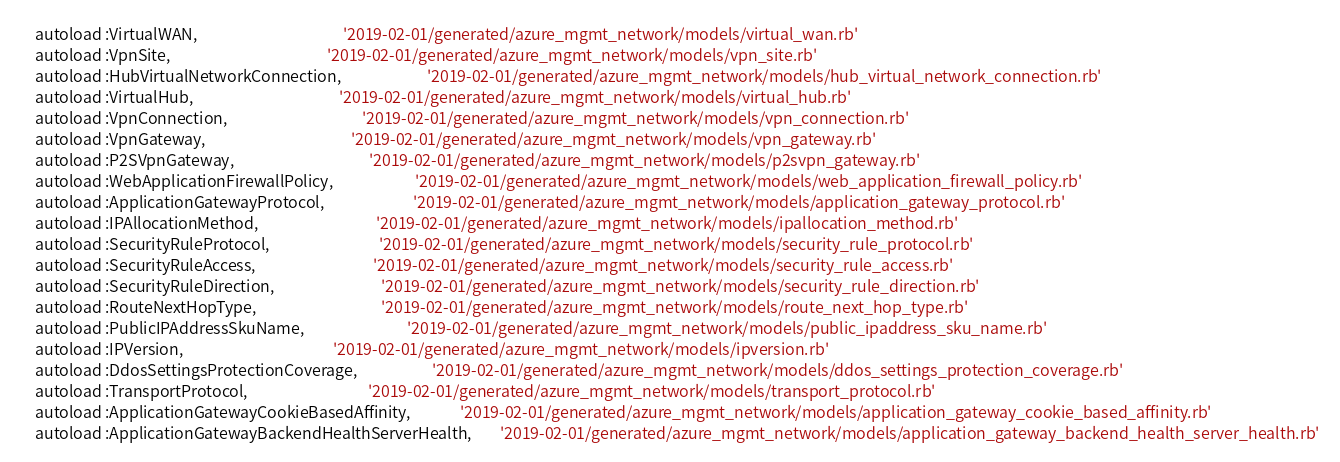Convert code to text. <code><loc_0><loc_0><loc_500><loc_500><_Ruby_>    autoload :VirtualWAN,                                         '2019-02-01/generated/azure_mgmt_network/models/virtual_wan.rb'
    autoload :VpnSite,                                            '2019-02-01/generated/azure_mgmt_network/models/vpn_site.rb'
    autoload :HubVirtualNetworkConnection,                        '2019-02-01/generated/azure_mgmt_network/models/hub_virtual_network_connection.rb'
    autoload :VirtualHub,                                         '2019-02-01/generated/azure_mgmt_network/models/virtual_hub.rb'
    autoload :VpnConnection,                                      '2019-02-01/generated/azure_mgmt_network/models/vpn_connection.rb'
    autoload :VpnGateway,                                         '2019-02-01/generated/azure_mgmt_network/models/vpn_gateway.rb'
    autoload :P2SVpnGateway,                                      '2019-02-01/generated/azure_mgmt_network/models/p2svpn_gateway.rb'
    autoload :WebApplicationFirewallPolicy,                       '2019-02-01/generated/azure_mgmt_network/models/web_application_firewall_policy.rb'
    autoload :ApplicationGatewayProtocol,                         '2019-02-01/generated/azure_mgmt_network/models/application_gateway_protocol.rb'
    autoload :IPAllocationMethod,                                 '2019-02-01/generated/azure_mgmt_network/models/ipallocation_method.rb'
    autoload :SecurityRuleProtocol,                               '2019-02-01/generated/azure_mgmt_network/models/security_rule_protocol.rb'
    autoload :SecurityRuleAccess,                                 '2019-02-01/generated/azure_mgmt_network/models/security_rule_access.rb'
    autoload :SecurityRuleDirection,                              '2019-02-01/generated/azure_mgmt_network/models/security_rule_direction.rb'
    autoload :RouteNextHopType,                                   '2019-02-01/generated/azure_mgmt_network/models/route_next_hop_type.rb'
    autoload :PublicIPAddressSkuName,                             '2019-02-01/generated/azure_mgmt_network/models/public_ipaddress_sku_name.rb'
    autoload :IPVersion,                                          '2019-02-01/generated/azure_mgmt_network/models/ipversion.rb'
    autoload :DdosSettingsProtectionCoverage,                     '2019-02-01/generated/azure_mgmt_network/models/ddos_settings_protection_coverage.rb'
    autoload :TransportProtocol,                                  '2019-02-01/generated/azure_mgmt_network/models/transport_protocol.rb'
    autoload :ApplicationGatewayCookieBasedAffinity,              '2019-02-01/generated/azure_mgmt_network/models/application_gateway_cookie_based_affinity.rb'
    autoload :ApplicationGatewayBackendHealthServerHealth,        '2019-02-01/generated/azure_mgmt_network/models/application_gateway_backend_health_server_health.rb'</code> 